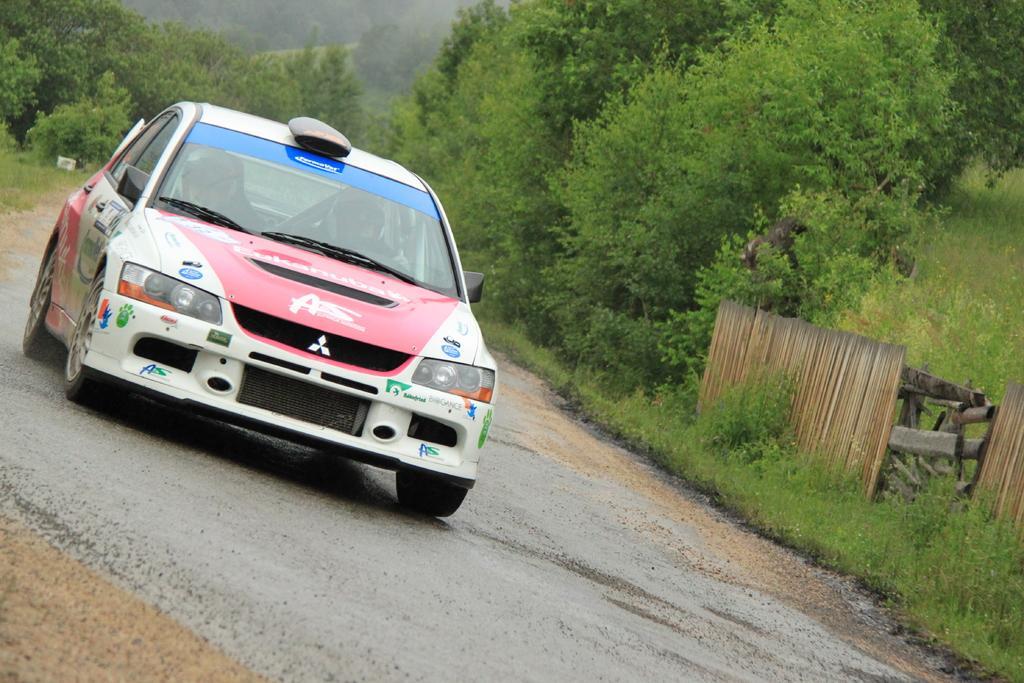Describe this image in one or two sentences. In this picture we can see a car on the road, wooden objects, plants, trees and in the background it is blurry. 